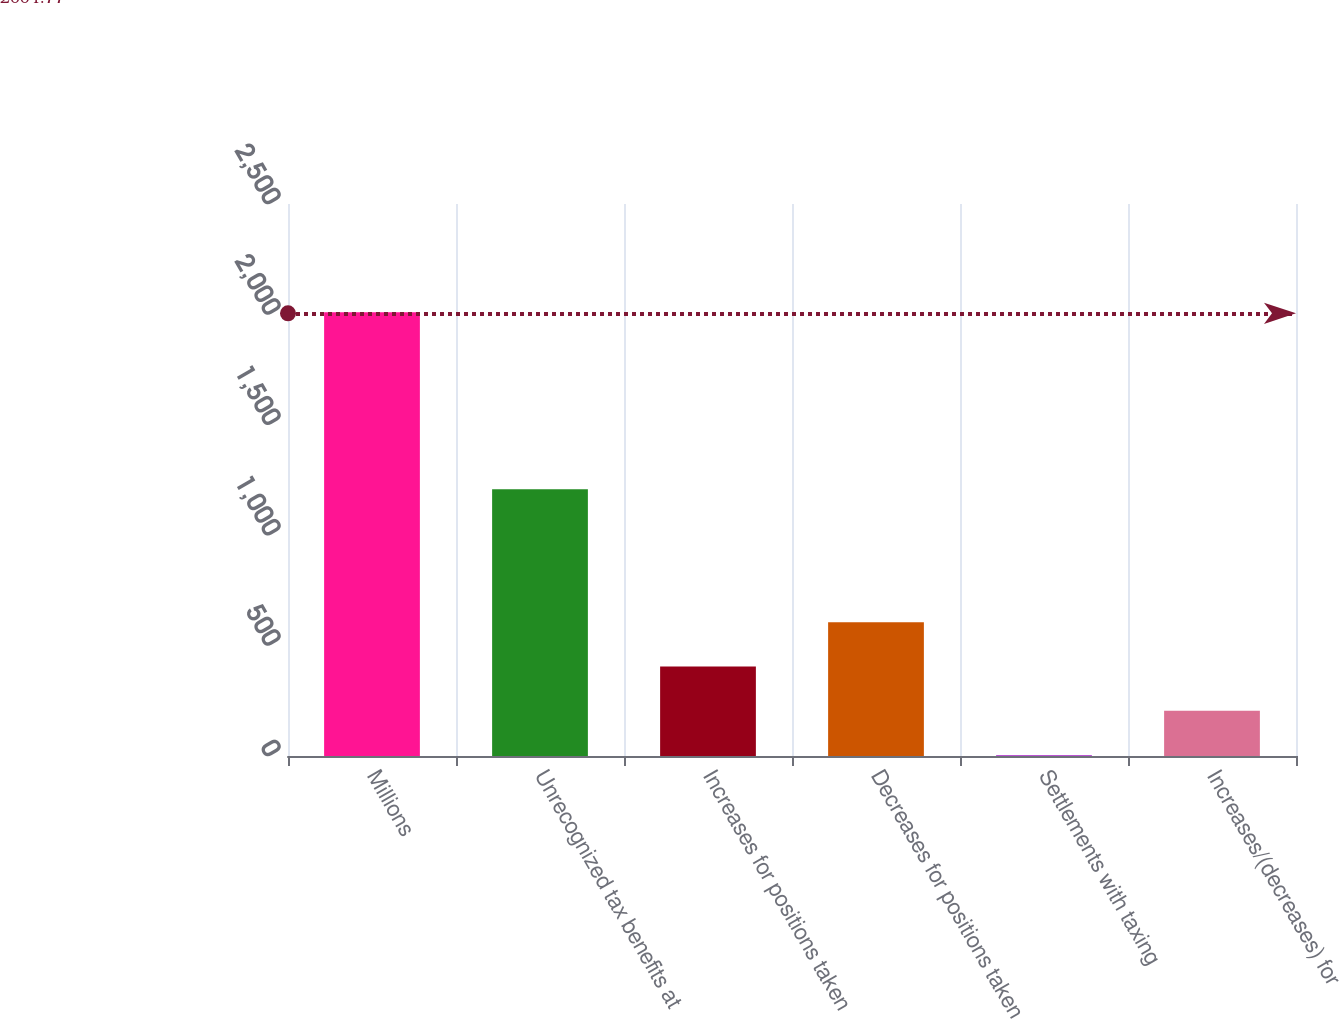<chart> <loc_0><loc_0><loc_500><loc_500><bar_chart><fcel>Millions<fcel>Unrecognized tax benefits at<fcel>Increases for positions taken<fcel>Decreases for positions taken<fcel>Settlements with taxing<fcel>Increases/(decreases) for<nl><fcel>2010<fcel>1207.6<fcel>405.2<fcel>605.8<fcel>4<fcel>204.6<nl></chart> 